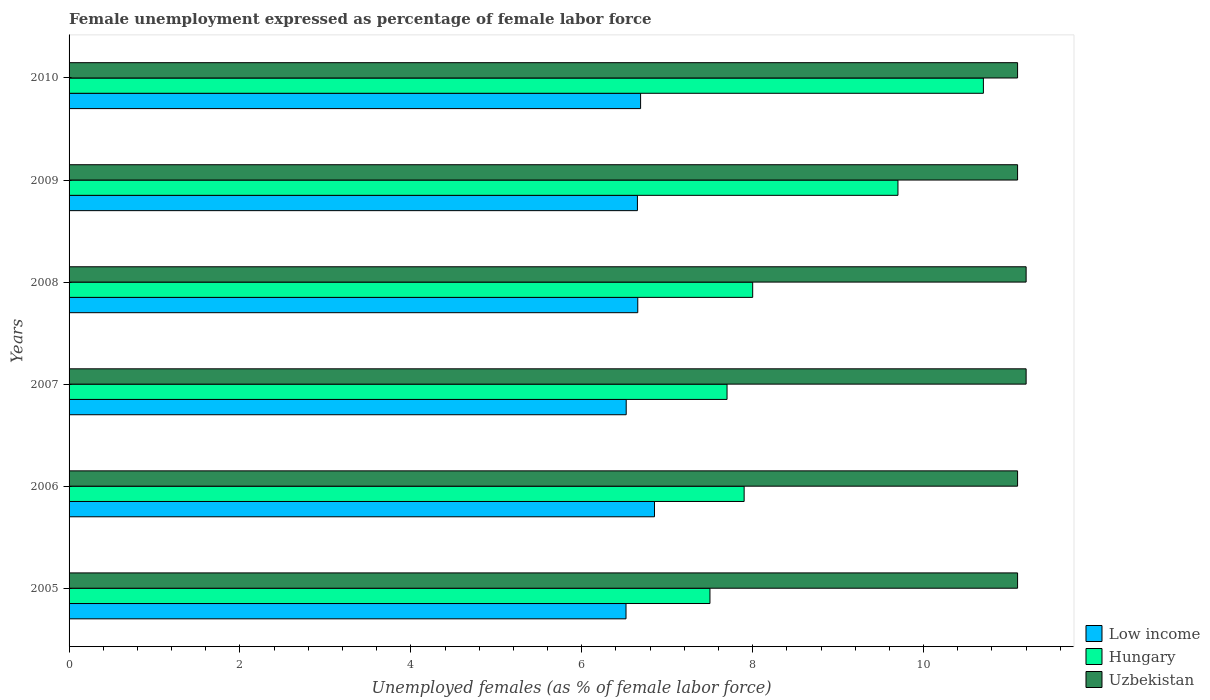How many groups of bars are there?
Offer a terse response. 6. Are the number of bars per tick equal to the number of legend labels?
Offer a very short reply. Yes. Are the number of bars on each tick of the Y-axis equal?
Provide a short and direct response. Yes. What is the label of the 2nd group of bars from the top?
Provide a short and direct response. 2009. What is the unemployment in females in in Low income in 2006?
Your answer should be very brief. 6.85. Across all years, what is the maximum unemployment in females in in Low income?
Ensure brevity in your answer.  6.85. Across all years, what is the minimum unemployment in females in in Low income?
Keep it short and to the point. 6.52. In which year was the unemployment in females in in Hungary minimum?
Your answer should be compact. 2005. What is the total unemployment in females in in Low income in the graph?
Your response must be concise. 39.88. What is the difference between the unemployment in females in in Uzbekistan in 2007 and that in 2010?
Your answer should be compact. 0.1. What is the difference between the unemployment in females in in Low income in 2010 and the unemployment in females in in Uzbekistan in 2007?
Ensure brevity in your answer.  -4.51. What is the average unemployment in females in in Hungary per year?
Give a very brief answer. 8.58. In the year 2005, what is the difference between the unemployment in females in in Uzbekistan and unemployment in females in in Low income?
Your answer should be compact. 4.58. What is the ratio of the unemployment in females in in Hungary in 2005 to that in 2007?
Keep it short and to the point. 0.97. Is the unemployment in females in in Low income in 2006 less than that in 2008?
Ensure brevity in your answer.  No. Is the difference between the unemployment in females in in Uzbekistan in 2006 and 2008 greater than the difference between the unemployment in females in in Low income in 2006 and 2008?
Offer a terse response. No. What is the difference between the highest and the second highest unemployment in females in in Low income?
Ensure brevity in your answer.  0.16. What is the difference between the highest and the lowest unemployment in females in in Uzbekistan?
Make the answer very short. 0.1. Is the sum of the unemployment in females in in Low income in 2006 and 2010 greater than the maximum unemployment in females in in Uzbekistan across all years?
Offer a terse response. Yes. What does the 3rd bar from the bottom in 2006 represents?
Provide a succinct answer. Uzbekistan. How many bars are there?
Ensure brevity in your answer.  18. How many years are there in the graph?
Provide a short and direct response. 6. Are the values on the major ticks of X-axis written in scientific E-notation?
Ensure brevity in your answer.  No. Does the graph contain any zero values?
Provide a short and direct response. No. Does the graph contain grids?
Your response must be concise. No. What is the title of the graph?
Provide a succinct answer. Female unemployment expressed as percentage of female labor force. Does "Germany" appear as one of the legend labels in the graph?
Offer a terse response. No. What is the label or title of the X-axis?
Provide a short and direct response. Unemployed females (as % of female labor force). What is the label or title of the Y-axis?
Keep it short and to the point. Years. What is the Unemployed females (as % of female labor force) of Low income in 2005?
Offer a very short reply. 6.52. What is the Unemployed females (as % of female labor force) of Hungary in 2005?
Your response must be concise. 7.5. What is the Unemployed females (as % of female labor force) in Uzbekistan in 2005?
Offer a terse response. 11.1. What is the Unemployed females (as % of female labor force) in Low income in 2006?
Offer a very short reply. 6.85. What is the Unemployed females (as % of female labor force) of Hungary in 2006?
Provide a succinct answer. 7.9. What is the Unemployed females (as % of female labor force) in Uzbekistan in 2006?
Your response must be concise. 11.1. What is the Unemployed females (as % of female labor force) in Low income in 2007?
Provide a succinct answer. 6.52. What is the Unemployed females (as % of female labor force) of Hungary in 2007?
Your answer should be compact. 7.7. What is the Unemployed females (as % of female labor force) of Uzbekistan in 2007?
Your answer should be compact. 11.2. What is the Unemployed females (as % of female labor force) of Low income in 2008?
Keep it short and to the point. 6.66. What is the Unemployed females (as % of female labor force) in Hungary in 2008?
Offer a very short reply. 8. What is the Unemployed females (as % of female labor force) in Uzbekistan in 2008?
Give a very brief answer. 11.2. What is the Unemployed females (as % of female labor force) in Low income in 2009?
Your answer should be compact. 6.65. What is the Unemployed females (as % of female labor force) in Hungary in 2009?
Offer a terse response. 9.7. What is the Unemployed females (as % of female labor force) of Uzbekistan in 2009?
Your answer should be compact. 11.1. What is the Unemployed females (as % of female labor force) in Low income in 2010?
Keep it short and to the point. 6.69. What is the Unemployed females (as % of female labor force) in Hungary in 2010?
Your response must be concise. 10.7. What is the Unemployed females (as % of female labor force) in Uzbekistan in 2010?
Provide a short and direct response. 11.1. Across all years, what is the maximum Unemployed females (as % of female labor force) in Low income?
Your answer should be compact. 6.85. Across all years, what is the maximum Unemployed females (as % of female labor force) in Hungary?
Your response must be concise. 10.7. Across all years, what is the maximum Unemployed females (as % of female labor force) in Uzbekistan?
Provide a succinct answer. 11.2. Across all years, what is the minimum Unemployed females (as % of female labor force) in Low income?
Provide a short and direct response. 6.52. Across all years, what is the minimum Unemployed females (as % of female labor force) of Hungary?
Your answer should be compact. 7.5. Across all years, what is the minimum Unemployed females (as % of female labor force) of Uzbekistan?
Your response must be concise. 11.1. What is the total Unemployed females (as % of female labor force) in Low income in the graph?
Your answer should be very brief. 39.88. What is the total Unemployed females (as % of female labor force) of Hungary in the graph?
Provide a succinct answer. 51.5. What is the total Unemployed females (as % of female labor force) of Uzbekistan in the graph?
Keep it short and to the point. 66.8. What is the difference between the Unemployed females (as % of female labor force) of Low income in 2005 and that in 2006?
Offer a very short reply. -0.33. What is the difference between the Unemployed females (as % of female labor force) in Hungary in 2005 and that in 2006?
Give a very brief answer. -0.4. What is the difference between the Unemployed females (as % of female labor force) of Uzbekistan in 2005 and that in 2006?
Your response must be concise. 0. What is the difference between the Unemployed females (as % of female labor force) of Low income in 2005 and that in 2007?
Offer a very short reply. -0. What is the difference between the Unemployed females (as % of female labor force) of Low income in 2005 and that in 2008?
Ensure brevity in your answer.  -0.14. What is the difference between the Unemployed females (as % of female labor force) in Low income in 2005 and that in 2009?
Ensure brevity in your answer.  -0.13. What is the difference between the Unemployed females (as % of female labor force) in Hungary in 2005 and that in 2009?
Provide a short and direct response. -2.2. What is the difference between the Unemployed females (as % of female labor force) in Low income in 2005 and that in 2010?
Provide a short and direct response. -0.17. What is the difference between the Unemployed females (as % of female labor force) of Hungary in 2005 and that in 2010?
Ensure brevity in your answer.  -3.2. What is the difference between the Unemployed females (as % of female labor force) in Uzbekistan in 2005 and that in 2010?
Provide a succinct answer. 0. What is the difference between the Unemployed females (as % of female labor force) in Low income in 2006 and that in 2007?
Make the answer very short. 0.33. What is the difference between the Unemployed females (as % of female labor force) of Hungary in 2006 and that in 2007?
Provide a short and direct response. 0.2. What is the difference between the Unemployed females (as % of female labor force) of Low income in 2006 and that in 2008?
Keep it short and to the point. 0.2. What is the difference between the Unemployed females (as % of female labor force) of Hungary in 2006 and that in 2008?
Provide a short and direct response. -0.1. What is the difference between the Unemployed females (as % of female labor force) in Uzbekistan in 2006 and that in 2008?
Make the answer very short. -0.1. What is the difference between the Unemployed females (as % of female labor force) of Low income in 2006 and that in 2009?
Your answer should be compact. 0.2. What is the difference between the Unemployed females (as % of female labor force) of Hungary in 2006 and that in 2009?
Keep it short and to the point. -1.8. What is the difference between the Unemployed females (as % of female labor force) of Low income in 2006 and that in 2010?
Your response must be concise. 0.16. What is the difference between the Unemployed females (as % of female labor force) in Hungary in 2006 and that in 2010?
Offer a very short reply. -2.8. What is the difference between the Unemployed females (as % of female labor force) of Low income in 2007 and that in 2008?
Your response must be concise. -0.14. What is the difference between the Unemployed females (as % of female labor force) of Low income in 2007 and that in 2009?
Make the answer very short. -0.13. What is the difference between the Unemployed females (as % of female labor force) of Hungary in 2007 and that in 2009?
Your response must be concise. -2. What is the difference between the Unemployed females (as % of female labor force) in Low income in 2007 and that in 2010?
Your answer should be compact. -0.17. What is the difference between the Unemployed females (as % of female labor force) in Hungary in 2007 and that in 2010?
Make the answer very short. -3. What is the difference between the Unemployed females (as % of female labor force) in Low income in 2008 and that in 2009?
Provide a succinct answer. 0. What is the difference between the Unemployed females (as % of female labor force) of Uzbekistan in 2008 and that in 2009?
Provide a succinct answer. 0.1. What is the difference between the Unemployed females (as % of female labor force) of Low income in 2008 and that in 2010?
Your answer should be very brief. -0.03. What is the difference between the Unemployed females (as % of female labor force) of Hungary in 2008 and that in 2010?
Your response must be concise. -2.7. What is the difference between the Unemployed females (as % of female labor force) of Low income in 2009 and that in 2010?
Your response must be concise. -0.04. What is the difference between the Unemployed females (as % of female labor force) of Uzbekistan in 2009 and that in 2010?
Your answer should be compact. 0. What is the difference between the Unemployed females (as % of female labor force) of Low income in 2005 and the Unemployed females (as % of female labor force) of Hungary in 2006?
Your answer should be very brief. -1.38. What is the difference between the Unemployed females (as % of female labor force) in Low income in 2005 and the Unemployed females (as % of female labor force) in Uzbekistan in 2006?
Give a very brief answer. -4.58. What is the difference between the Unemployed females (as % of female labor force) in Low income in 2005 and the Unemployed females (as % of female labor force) in Hungary in 2007?
Your response must be concise. -1.18. What is the difference between the Unemployed females (as % of female labor force) in Low income in 2005 and the Unemployed females (as % of female labor force) in Uzbekistan in 2007?
Offer a terse response. -4.68. What is the difference between the Unemployed females (as % of female labor force) in Low income in 2005 and the Unemployed females (as % of female labor force) in Hungary in 2008?
Your answer should be compact. -1.48. What is the difference between the Unemployed females (as % of female labor force) of Low income in 2005 and the Unemployed females (as % of female labor force) of Uzbekistan in 2008?
Provide a short and direct response. -4.68. What is the difference between the Unemployed females (as % of female labor force) of Low income in 2005 and the Unemployed females (as % of female labor force) of Hungary in 2009?
Give a very brief answer. -3.18. What is the difference between the Unemployed females (as % of female labor force) in Low income in 2005 and the Unemployed females (as % of female labor force) in Uzbekistan in 2009?
Your answer should be compact. -4.58. What is the difference between the Unemployed females (as % of female labor force) in Hungary in 2005 and the Unemployed females (as % of female labor force) in Uzbekistan in 2009?
Make the answer very short. -3.6. What is the difference between the Unemployed females (as % of female labor force) in Low income in 2005 and the Unemployed females (as % of female labor force) in Hungary in 2010?
Make the answer very short. -4.18. What is the difference between the Unemployed females (as % of female labor force) of Low income in 2005 and the Unemployed females (as % of female labor force) of Uzbekistan in 2010?
Offer a terse response. -4.58. What is the difference between the Unemployed females (as % of female labor force) in Low income in 2006 and the Unemployed females (as % of female labor force) in Hungary in 2007?
Your answer should be compact. -0.85. What is the difference between the Unemployed females (as % of female labor force) of Low income in 2006 and the Unemployed females (as % of female labor force) of Uzbekistan in 2007?
Offer a terse response. -4.35. What is the difference between the Unemployed females (as % of female labor force) in Hungary in 2006 and the Unemployed females (as % of female labor force) in Uzbekistan in 2007?
Your answer should be very brief. -3.3. What is the difference between the Unemployed females (as % of female labor force) of Low income in 2006 and the Unemployed females (as % of female labor force) of Hungary in 2008?
Make the answer very short. -1.15. What is the difference between the Unemployed females (as % of female labor force) of Low income in 2006 and the Unemployed females (as % of female labor force) of Uzbekistan in 2008?
Your answer should be very brief. -4.35. What is the difference between the Unemployed females (as % of female labor force) in Low income in 2006 and the Unemployed females (as % of female labor force) in Hungary in 2009?
Your response must be concise. -2.85. What is the difference between the Unemployed females (as % of female labor force) of Low income in 2006 and the Unemployed females (as % of female labor force) of Uzbekistan in 2009?
Offer a terse response. -4.25. What is the difference between the Unemployed females (as % of female labor force) of Hungary in 2006 and the Unemployed females (as % of female labor force) of Uzbekistan in 2009?
Provide a short and direct response. -3.2. What is the difference between the Unemployed females (as % of female labor force) of Low income in 2006 and the Unemployed females (as % of female labor force) of Hungary in 2010?
Ensure brevity in your answer.  -3.85. What is the difference between the Unemployed females (as % of female labor force) in Low income in 2006 and the Unemployed females (as % of female labor force) in Uzbekistan in 2010?
Offer a terse response. -4.25. What is the difference between the Unemployed females (as % of female labor force) in Low income in 2007 and the Unemployed females (as % of female labor force) in Hungary in 2008?
Provide a succinct answer. -1.48. What is the difference between the Unemployed females (as % of female labor force) of Low income in 2007 and the Unemployed females (as % of female labor force) of Uzbekistan in 2008?
Keep it short and to the point. -4.68. What is the difference between the Unemployed females (as % of female labor force) in Low income in 2007 and the Unemployed females (as % of female labor force) in Hungary in 2009?
Provide a short and direct response. -3.18. What is the difference between the Unemployed females (as % of female labor force) in Low income in 2007 and the Unemployed females (as % of female labor force) in Uzbekistan in 2009?
Your answer should be very brief. -4.58. What is the difference between the Unemployed females (as % of female labor force) of Hungary in 2007 and the Unemployed females (as % of female labor force) of Uzbekistan in 2009?
Provide a short and direct response. -3.4. What is the difference between the Unemployed females (as % of female labor force) in Low income in 2007 and the Unemployed females (as % of female labor force) in Hungary in 2010?
Your answer should be compact. -4.18. What is the difference between the Unemployed females (as % of female labor force) in Low income in 2007 and the Unemployed females (as % of female labor force) in Uzbekistan in 2010?
Your answer should be compact. -4.58. What is the difference between the Unemployed females (as % of female labor force) in Low income in 2008 and the Unemployed females (as % of female labor force) in Hungary in 2009?
Offer a terse response. -3.04. What is the difference between the Unemployed females (as % of female labor force) of Low income in 2008 and the Unemployed females (as % of female labor force) of Uzbekistan in 2009?
Your answer should be very brief. -4.44. What is the difference between the Unemployed females (as % of female labor force) of Low income in 2008 and the Unemployed females (as % of female labor force) of Hungary in 2010?
Provide a short and direct response. -4.04. What is the difference between the Unemployed females (as % of female labor force) in Low income in 2008 and the Unemployed females (as % of female labor force) in Uzbekistan in 2010?
Ensure brevity in your answer.  -4.44. What is the difference between the Unemployed females (as % of female labor force) of Hungary in 2008 and the Unemployed females (as % of female labor force) of Uzbekistan in 2010?
Ensure brevity in your answer.  -3.1. What is the difference between the Unemployed females (as % of female labor force) in Low income in 2009 and the Unemployed females (as % of female labor force) in Hungary in 2010?
Offer a very short reply. -4.05. What is the difference between the Unemployed females (as % of female labor force) of Low income in 2009 and the Unemployed females (as % of female labor force) of Uzbekistan in 2010?
Provide a succinct answer. -4.45. What is the difference between the Unemployed females (as % of female labor force) in Hungary in 2009 and the Unemployed females (as % of female labor force) in Uzbekistan in 2010?
Your answer should be very brief. -1.4. What is the average Unemployed females (as % of female labor force) in Low income per year?
Ensure brevity in your answer.  6.65. What is the average Unemployed females (as % of female labor force) in Hungary per year?
Your answer should be very brief. 8.58. What is the average Unemployed females (as % of female labor force) of Uzbekistan per year?
Offer a very short reply. 11.13. In the year 2005, what is the difference between the Unemployed females (as % of female labor force) of Low income and Unemployed females (as % of female labor force) of Hungary?
Your response must be concise. -0.98. In the year 2005, what is the difference between the Unemployed females (as % of female labor force) of Low income and Unemployed females (as % of female labor force) of Uzbekistan?
Offer a terse response. -4.58. In the year 2006, what is the difference between the Unemployed females (as % of female labor force) in Low income and Unemployed females (as % of female labor force) in Hungary?
Your answer should be compact. -1.05. In the year 2006, what is the difference between the Unemployed females (as % of female labor force) in Low income and Unemployed females (as % of female labor force) in Uzbekistan?
Offer a very short reply. -4.25. In the year 2006, what is the difference between the Unemployed females (as % of female labor force) in Hungary and Unemployed females (as % of female labor force) in Uzbekistan?
Ensure brevity in your answer.  -3.2. In the year 2007, what is the difference between the Unemployed females (as % of female labor force) in Low income and Unemployed females (as % of female labor force) in Hungary?
Provide a short and direct response. -1.18. In the year 2007, what is the difference between the Unemployed females (as % of female labor force) of Low income and Unemployed females (as % of female labor force) of Uzbekistan?
Offer a very short reply. -4.68. In the year 2008, what is the difference between the Unemployed females (as % of female labor force) in Low income and Unemployed females (as % of female labor force) in Hungary?
Offer a very short reply. -1.34. In the year 2008, what is the difference between the Unemployed females (as % of female labor force) of Low income and Unemployed females (as % of female labor force) of Uzbekistan?
Provide a succinct answer. -4.54. In the year 2009, what is the difference between the Unemployed females (as % of female labor force) of Low income and Unemployed females (as % of female labor force) of Hungary?
Your answer should be very brief. -3.05. In the year 2009, what is the difference between the Unemployed females (as % of female labor force) of Low income and Unemployed females (as % of female labor force) of Uzbekistan?
Your response must be concise. -4.45. In the year 2009, what is the difference between the Unemployed females (as % of female labor force) of Hungary and Unemployed females (as % of female labor force) of Uzbekistan?
Keep it short and to the point. -1.4. In the year 2010, what is the difference between the Unemployed females (as % of female labor force) of Low income and Unemployed females (as % of female labor force) of Hungary?
Provide a short and direct response. -4.01. In the year 2010, what is the difference between the Unemployed females (as % of female labor force) in Low income and Unemployed females (as % of female labor force) in Uzbekistan?
Give a very brief answer. -4.41. In the year 2010, what is the difference between the Unemployed females (as % of female labor force) in Hungary and Unemployed females (as % of female labor force) in Uzbekistan?
Your answer should be very brief. -0.4. What is the ratio of the Unemployed females (as % of female labor force) of Low income in 2005 to that in 2006?
Your response must be concise. 0.95. What is the ratio of the Unemployed females (as % of female labor force) of Hungary in 2005 to that in 2006?
Provide a short and direct response. 0.95. What is the ratio of the Unemployed females (as % of female labor force) in Uzbekistan in 2005 to that in 2006?
Keep it short and to the point. 1. What is the ratio of the Unemployed females (as % of female labor force) of Hungary in 2005 to that in 2007?
Your answer should be compact. 0.97. What is the ratio of the Unemployed females (as % of female labor force) of Low income in 2005 to that in 2008?
Your answer should be very brief. 0.98. What is the ratio of the Unemployed females (as % of female labor force) of Hungary in 2005 to that in 2008?
Your answer should be compact. 0.94. What is the ratio of the Unemployed females (as % of female labor force) of Uzbekistan in 2005 to that in 2008?
Offer a terse response. 0.99. What is the ratio of the Unemployed females (as % of female labor force) of Low income in 2005 to that in 2009?
Your answer should be very brief. 0.98. What is the ratio of the Unemployed females (as % of female labor force) in Hungary in 2005 to that in 2009?
Ensure brevity in your answer.  0.77. What is the ratio of the Unemployed females (as % of female labor force) in Uzbekistan in 2005 to that in 2009?
Your answer should be very brief. 1. What is the ratio of the Unemployed females (as % of female labor force) in Low income in 2005 to that in 2010?
Your response must be concise. 0.97. What is the ratio of the Unemployed females (as % of female labor force) in Hungary in 2005 to that in 2010?
Give a very brief answer. 0.7. What is the ratio of the Unemployed females (as % of female labor force) of Low income in 2006 to that in 2007?
Keep it short and to the point. 1.05. What is the ratio of the Unemployed females (as % of female labor force) of Hungary in 2006 to that in 2007?
Your response must be concise. 1.03. What is the ratio of the Unemployed females (as % of female labor force) in Uzbekistan in 2006 to that in 2007?
Your answer should be very brief. 0.99. What is the ratio of the Unemployed females (as % of female labor force) of Low income in 2006 to that in 2008?
Provide a short and direct response. 1.03. What is the ratio of the Unemployed females (as % of female labor force) in Hungary in 2006 to that in 2008?
Your answer should be very brief. 0.99. What is the ratio of the Unemployed females (as % of female labor force) in Low income in 2006 to that in 2009?
Ensure brevity in your answer.  1.03. What is the ratio of the Unemployed females (as % of female labor force) of Hungary in 2006 to that in 2009?
Ensure brevity in your answer.  0.81. What is the ratio of the Unemployed females (as % of female labor force) in Low income in 2006 to that in 2010?
Ensure brevity in your answer.  1.02. What is the ratio of the Unemployed females (as % of female labor force) in Hungary in 2006 to that in 2010?
Ensure brevity in your answer.  0.74. What is the ratio of the Unemployed females (as % of female labor force) in Uzbekistan in 2006 to that in 2010?
Offer a terse response. 1. What is the ratio of the Unemployed females (as % of female labor force) of Low income in 2007 to that in 2008?
Your answer should be compact. 0.98. What is the ratio of the Unemployed females (as % of female labor force) in Hungary in 2007 to that in 2008?
Provide a succinct answer. 0.96. What is the ratio of the Unemployed females (as % of female labor force) in Uzbekistan in 2007 to that in 2008?
Keep it short and to the point. 1. What is the ratio of the Unemployed females (as % of female labor force) of Low income in 2007 to that in 2009?
Your answer should be compact. 0.98. What is the ratio of the Unemployed females (as % of female labor force) of Hungary in 2007 to that in 2009?
Offer a very short reply. 0.79. What is the ratio of the Unemployed females (as % of female labor force) of Uzbekistan in 2007 to that in 2009?
Offer a terse response. 1.01. What is the ratio of the Unemployed females (as % of female labor force) of Low income in 2007 to that in 2010?
Offer a very short reply. 0.97. What is the ratio of the Unemployed females (as % of female labor force) in Hungary in 2007 to that in 2010?
Offer a very short reply. 0.72. What is the ratio of the Unemployed females (as % of female labor force) in Low income in 2008 to that in 2009?
Make the answer very short. 1. What is the ratio of the Unemployed females (as % of female labor force) of Hungary in 2008 to that in 2009?
Make the answer very short. 0.82. What is the ratio of the Unemployed females (as % of female labor force) in Uzbekistan in 2008 to that in 2009?
Your answer should be very brief. 1.01. What is the ratio of the Unemployed females (as % of female labor force) in Low income in 2008 to that in 2010?
Keep it short and to the point. 1. What is the ratio of the Unemployed females (as % of female labor force) in Hungary in 2008 to that in 2010?
Make the answer very short. 0.75. What is the ratio of the Unemployed females (as % of female labor force) of Low income in 2009 to that in 2010?
Your response must be concise. 0.99. What is the ratio of the Unemployed females (as % of female labor force) of Hungary in 2009 to that in 2010?
Make the answer very short. 0.91. What is the difference between the highest and the second highest Unemployed females (as % of female labor force) in Low income?
Your response must be concise. 0.16. What is the difference between the highest and the lowest Unemployed females (as % of female labor force) in Uzbekistan?
Ensure brevity in your answer.  0.1. 